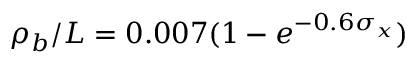<formula> <loc_0><loc_0><loc_500><loc_500>\rho _ { b } / L = 0 . 0 0 7 ( 1 - e ^ { - 0 . 6 \sigma _ { x } } )</formula> 